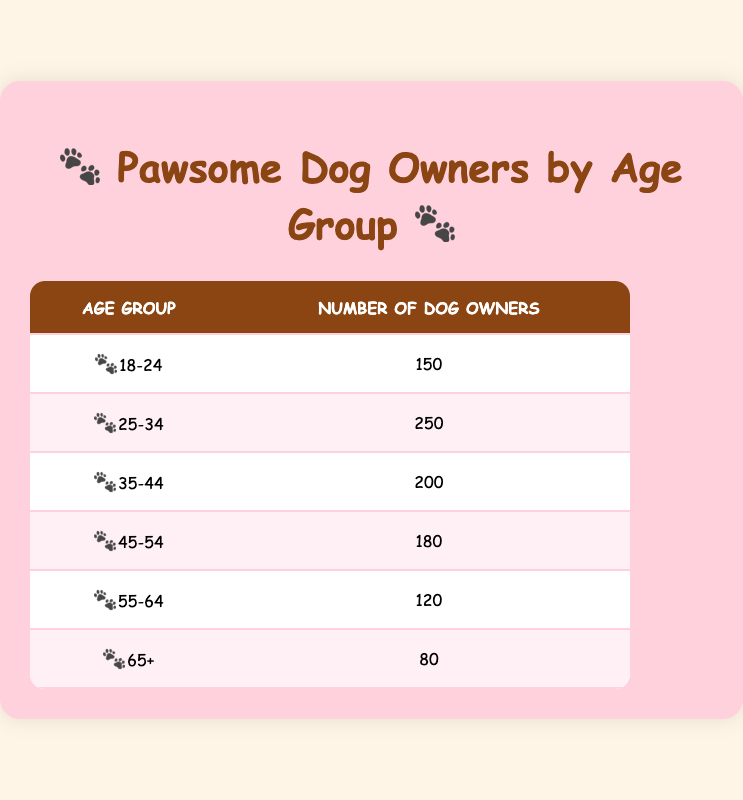What is the total number of dog owners in the age group 25-34? The table shows that there are 250 dog owners in the age group 25-34.
Answer: 250 Which age group has the highest number of dog owners? By looking at the table, the age group 25-34 has the highest number of dog owners, with 250 owners.
Answer: 25-34 What is the sum of dog owners in the age groups 45-54 and 55-64? The number of dog owners in the age group 45-54 is 180 and in the age group 55-64 is 120. Adding these gives 180 + 120 = 300.
Answer: 300 Is there a greater number of dog owners in the age group 35-44 than in the age group 65+? The age group 35-44 has 200 dog owners, while the age group 65+ has 80 owners. Since 200 is greater than 80, the statement is true.
Answer: Yes What is the average number of dog owners across all age groups? The total number of dog owners is the sum of those in all age groups: 150 + 250 + 200 + 180 + 120 + 80 = 1080. There are 6 age groups, so the average is 1080 / 6 = 180.
Answer: 180 How many more dog owners are in the age group 18-24 compared to the age group 65+? The age group 18-24 has 150 dog owners and the age group 65+ has 80. Subtracting gives 150 - 80 = 70, indicating there are 70 more dog owners in the 18-24 group.
Answer: 70 Does the age group 55-64 have fewer dog owners than the age group 45-54? The age group 55-64 has 120 dog owners, while the age group 45-54 has 180. Since 120 is less than 180, the statement is true.
Answer: Yes What age group has the least number of dog owners? The table indicates that the age group 65+ has the least number of dog owners, with only 80 owners.
Answer: 65+ How many dog owners are there in the age group 35-44 compared to the total number of owners in all age groups? The number of owners in the age group 35-44 is 200. The total number of dog owners is 1080, so comparing gives 200 is certainly less than 1080.
Answer: 200 